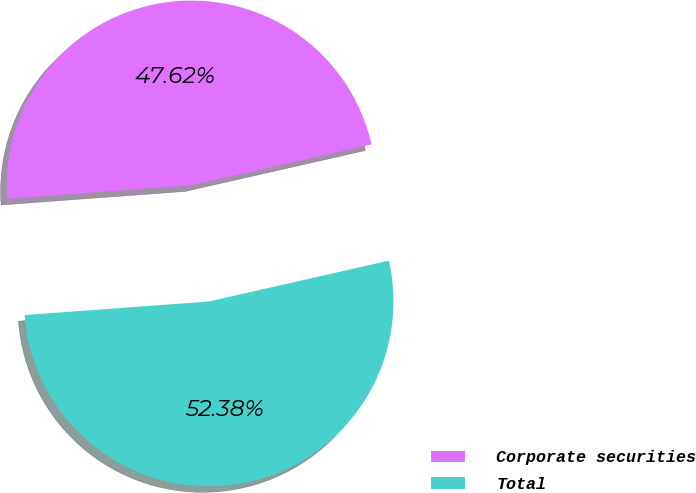<chart> <loc_0><loc_0><loc_500><loc_500><pie_chart><fcel>Corporate securities<fcel>Total<nl><fcel>47.62%<fcel>52.38%<nl></chart> 